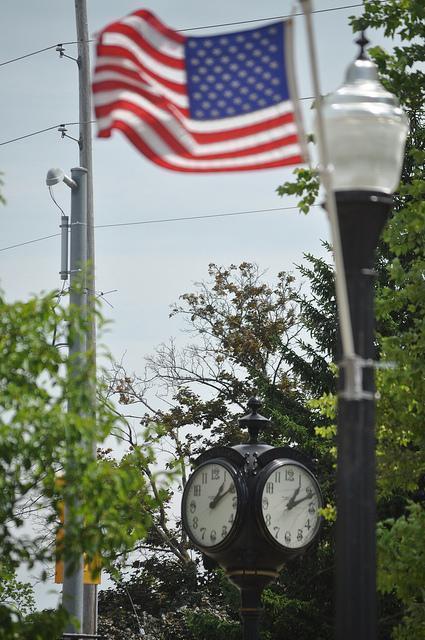How many clocks are visible?
Give a very brief answer. 2. 